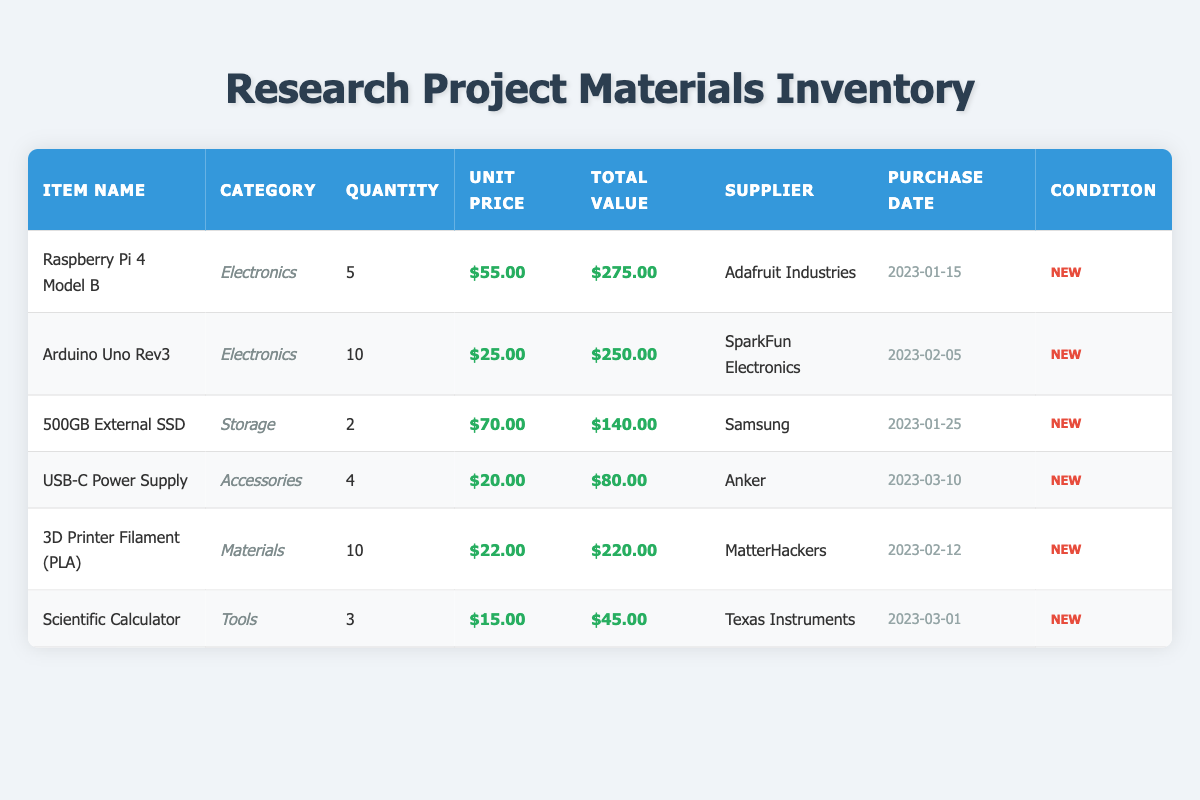What is the total quantity of items in the inventory? To find the total quantity of items, we need to sum the quantities from each row in the inventory: 5 (Raspberry Pi) + 10 (Arduino) + 2 (External SSD) + 4 (Power Supply) + 10 (Filament) + 3 (Calculator) = 34.
Answer: 34 Which item has the highest total value? From the total value column, the items are: Raspberry Pi: 275, Arduino: 250, External SSD: 140, Power Supply: 80, Filament: 220, and Calculator: 45. The highest total value is 275, which belongs to the Raspberry Pi.
Answer: Raspberry Pi 4 Model B How much did the 3D Printer Filament cost per unit? The unit price for the 3D Printer Filament (PLA) is given directly in the table as $22.00.
Answer: $22.00 Is the Scientific Calculator in new condition? The condition for the Scientific Calculator is stated as "New" in the table. Therefore, the answer is yes.
Answer: Yes What is the combined total value of all electronic items? The electronic items are: Raspberry Pi (275) and Arduino (250). Adding these values gives: 275 + 250 = 525.
Answer: 525 What percentage of the total inventory value is represented by the 500GB External SSD? First, we need to find the total inventory value by summing: 275 + 250 + 140 + 80 + 220 + 45 = 1010. Then, calculate the percentage: (140 / 1010) * 100 = 13.86%.
Answer: 13.86% Which supplier provided the most items? Counting the quantity per supplier: Adafruit: 5, SparkFun: 10, Samsung: 2, Anker: 4, MatterHackers: 10, and Texas Instruments: 3. The highest value is 10 from SparkFun and MatterHackers, meaning they both have the most items.
Answer: SparkFun Electronics and MatterHackers How many items were purchased after February 10, 2023? From the purchase dates, we see that the items purchased after February 10 are the USB-C Power Supply (March 10) and the Scientific Calculator (March 1). Counting these gives a total of 3 items.
Answer: 3 Are there any items supplied by Samsung? The table indicates there is an item supplied by Samsung, specifically the 500GB External SSD. Hence, the answer here is yes.
Answer: Yes 